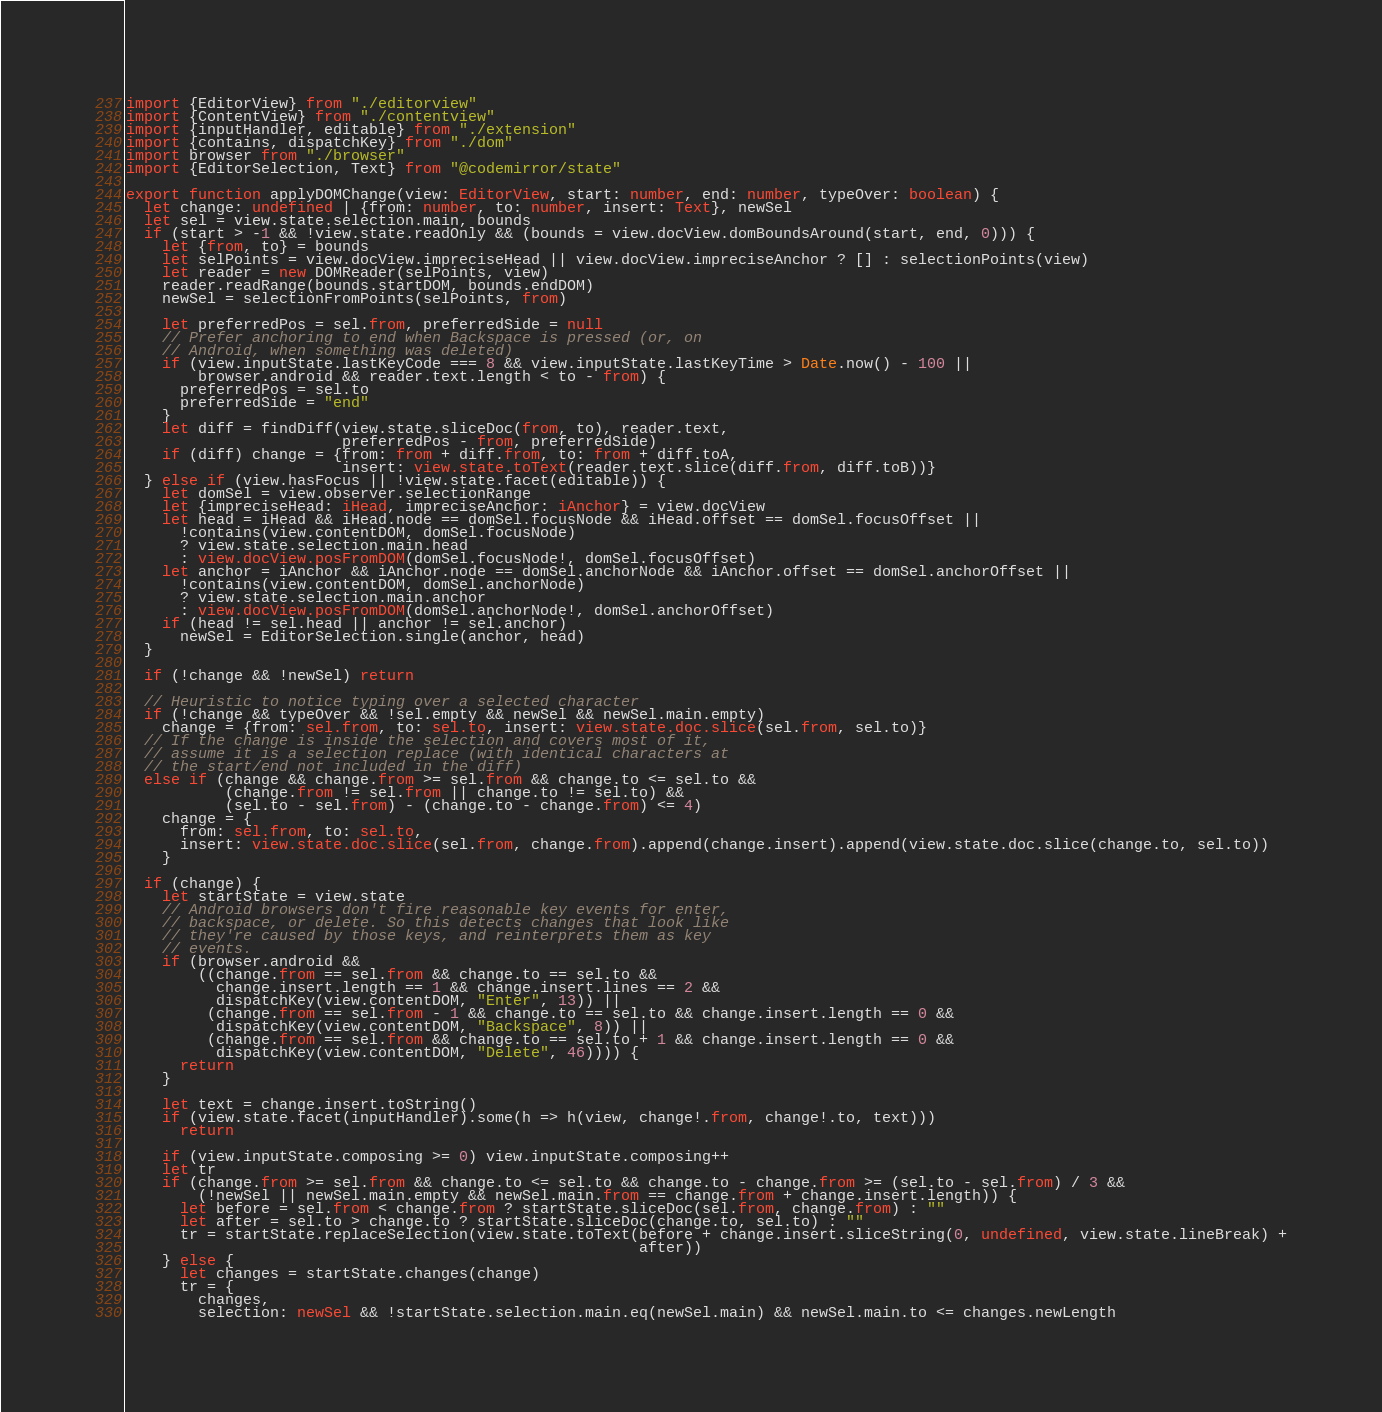Convert code to text. <code><loc_0><loc_0><loc_500><loc_500><_TypeScript_>import {EditorView} from "./editorview"
import {ContentView} from "./contentview"
import {inputHandler, editable} from "./extension"
import {contains, dispatchKey} from "./dom"
import browser from "./browser"
import {EditorSelection, Text} from "@codemirror/state"

export function applyDOMChange(view: EditorView, start: number, end: number, typeOver: boolean) {
  let change: undefined | {from: number, to: number, insert: Text}, newSel
  let sel = view.state.selection.main, bounds
  if (start > -1 && !view.state.readOnly && (bounds = view.docView.domBoundsAround(start, end, 0))) {
    let {from, to} = bounds
    let selPoints = view.docView.impreciseHead || view.docView.impreciseAnchor ? [] : selectionPoints(view)
    let reader = new DOMReader(selPoints, view)
    reader.readRange(bounds.startDOM, bounds.endDOM)
    newSel = selectionFromPoints(selPoints, from)

    let preferredPos = sel.from, preferredSide = null
    // Prefer anchoring to end when Backspace is pressed (or, on
    // Android, when something was deleted)
    if (view.inputState.lastKeyCode === 8 && view.inputState.lastKeyTime > Date.now() - 100 ||
        browser.android && reader.text.length < to - from) {
      preferredPos = sel.to
      preferredSide = "end"
    }
    let diff = findDiff(view.state.sliceDoc(from, to), reader.text,
                        preferredPos - from, preferredSide)
    if (diff) change = {from: from + diff.from, to: from + diff.toA,
                        insert: view.state.toText(reader.text.slice(diff.from, diff.toB))}
  } else if (view.hasFocus || !view.state.facet(editable)) {
    let domSel = view.observer.selectionRange
    let {impreciseHead: iHead, impreciseAnchor: iAnchor} = view.docView
    let head = iHead && iHead.node == domSel.focusNode && iHead.offset == domSel.focusOffset ||
      !contains(view.contentDOM, domSel.focusNode)
      ? view.state.selection.main.head
      : view.docView.posFromDOM(domSel.focusNode!, domSel.focusOffset)
    let anchor = iAnchor && iAnchor.node == domSel.anchorNode && iAnchor.offset == domSel.anchorOffset ||
      !contains(view.contentDOM, domSel.anchorNode)
      ? view.state.selection.main.anchor
      : view.docView.posFromDOM(domSel.anchorNode!, domSel.anchorOffset)
    if (head != sel.head || anchor != sel.anchor)
      newSel = EditorSelection.single(anchor, head)
  }

  if (!change && !newSel) return

  // Heuristic to notice typing over a selected character
  if (!change && typeOver && !sel.empty && newSel && newSel.main.empty)
    change = {from: sel.from, to: sel.to, insert: view.state.doc.slice(sel.from, sel.to)}
  // If the change is inside the selection and covers most of it,
  // assume it is a selection replace (with identical characters at
  // the start/end not included in the diff)
  else if (change && change.from >= sel.from && change.to <= sel.to &&
           (change.from != sel.from || change.to != sel.to) &&
           (sel.to - sel.from) - (change.to - change.from) <= 4)
    change = {
      from: sel.from, to: sel.to,
      insert: view.state.doc.slice(sel.from, change.from).append(change.insert).append(view.state.doc.slice(change.to, sel.to))
    }

  if (change) {
    let startState = view.state
    // Android browsers don't fire reasonable key events for enter,
    // backspace, or delete. So this detects changes that look like
    // they're caused by those keys, and reinterprets them as key
    // events.
    if (browser.android &&
        ((change.from == sel.from && change.to == sel.to &&
          change.insert.length == 1 && change.insert.lines == 2 &&
          dispatchKey(view.contentDOM, "Enter", 13)) ||
         (change.from == sel.from - 1 && change.to == sel.to && change.insert.length == 0 &&
          dispatchKey(view.contentDOM, "Backspace", 8)) ||
         (change.from == sel.from && change.to == sel.to + 1 && change.insert.length == 0 &&
          dispatchKey(view.contentDOM, "Delete", 46)))) {
      return
    }

    let text = change.insert.toString()
    if (view.state.facet(inputHandler).some(h => h(view, change!.from, change!.to, text)))
      return

    if (view.inputState.composing >= 0) view.inputState.composing++
    let tr
    if (change.from >= sel.from && change.to <= sel.to && change.to - change.from >= (sel.to - sel.from) / 3 &&
        (!newSel || newSel.main.empty && newSel.main.from == change.from + change.insert.length)) {
      let before = sel.from < change.from ? startState.sliceDoc(sel.from, change.from) : ""
      let after = sel.to > change.to ? startState.sliceDoc(change.to, sel.to) : ""
      tr = startState.replaceSelection(view.state.toText(before + change.insert.sliceString(0, undefined, view.state.lineBreak) +
                                                         after))
    } else {
      let changes = startState.changes(change)
      tr = {
        changes,
        selection: newSel && !startState.selection.main.eq(newSel.main) && newSel.main.to <= changes.newLength</code> 